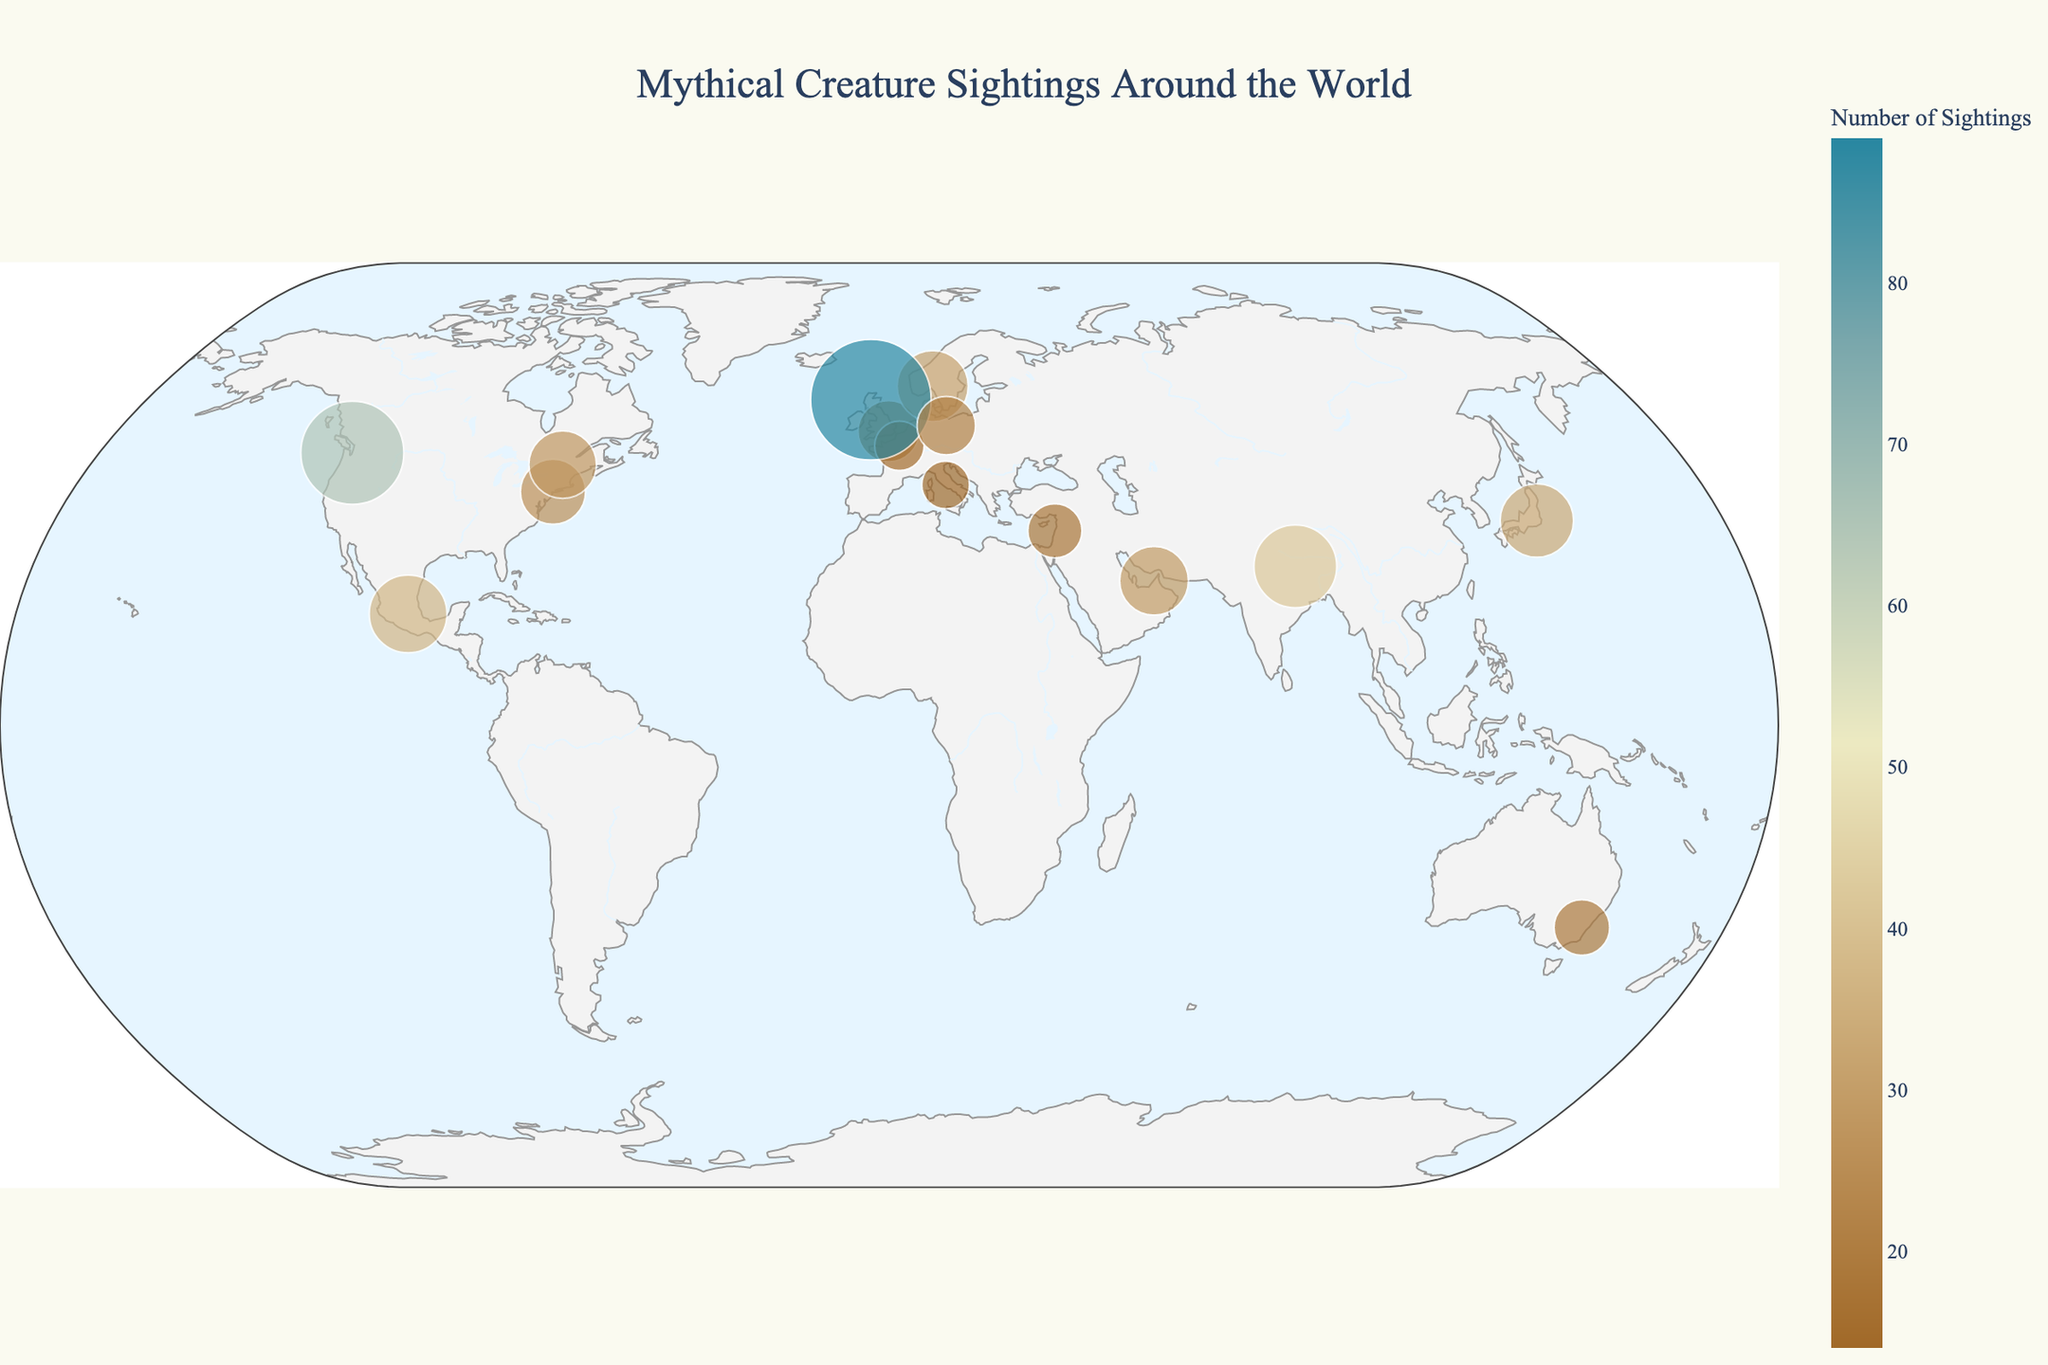What is the title of the figure? The title of the figure is usually located at the top of the plot and provides a summary of what the figure is about. In this case, the title is "Mythical Creature Sightings Around the World".
Answer: Mythical Creature Sightings Around the World Which mythical creature has the highest number of sightings? To determine this, look at the size and color of the points on the map. The legend indicates that larger and darker-colored points represent higher sightings. The Loch Ness Monster has the largest and darkest point.
Answer: Loch Ness Monster How many mythical creature sightings are reported for Bigfoot? Hover over or look at the size of the point labeled "Bigfoot" on the map. The legend indicates the number of sightings associated with each creature. In the map, Bigfoot has 65 sightings.
Answer: 65 Which creatures have sightings in Europe? Identify the points located in the European region of the map and look at their labels. Europe contains sightings for Werewolf (Berlin), Dragon (London), Unicorn (Paris), and Basilisk (Rome).
Answer: Werewolf, Dragon, Unicorn, Basilisk Compare the number of sightings between the Kraken and the Kappa. Which has more sightings? To compare, look at the points labeled "Kraken" and "Kappa" and their associated sizes/colors. Kraken has 31 sightings, and Kappa has 33 sightings.
Answer: Kappa What is the average number of sightings for Thunderbirds, Phoenixes, and Mermaids? First, find the number of sightings for each creature: Thunderbird (26), Phoenix (18), and Mermaid (29). Add these together and then divide by the count of creatures (3). The average is (26 + 18 + 29) / 3 = 24.33.
Answer: 24.33 Which mythical creature is reported more frequently in North America, Chupacabra or Wendigo? Find the points labeled "Chupacabra" and "Wendigo" on the North American portion of the map. Compare their sizes/colors. Chupacabra has 37 sightings, and Wendigo has 28 sightings.
Answer: Chupacabra Identify the creature with the least number of sightings and state the number. Look for the smallest and lightest-colored point on the map. The Basilisk has the smallest point, indicating 14 sightings as the least number.
Answer: Basilisk (14 sightings) How does the number of Kraken sightings compare to the number of Yeti sightings? Compare the sizes and colors of the points labeled "Kraken" and "Yeti." Kraken has 31 sightings while Yeti has 42.
Answer: Yeti has more sightings than Kraken What creature has a significant number of sightings in South Asia? Locate South Asia on the map and find the labeled point. The Yeti has a significant number of sightings (42) in this region.
Answer: Yeti 